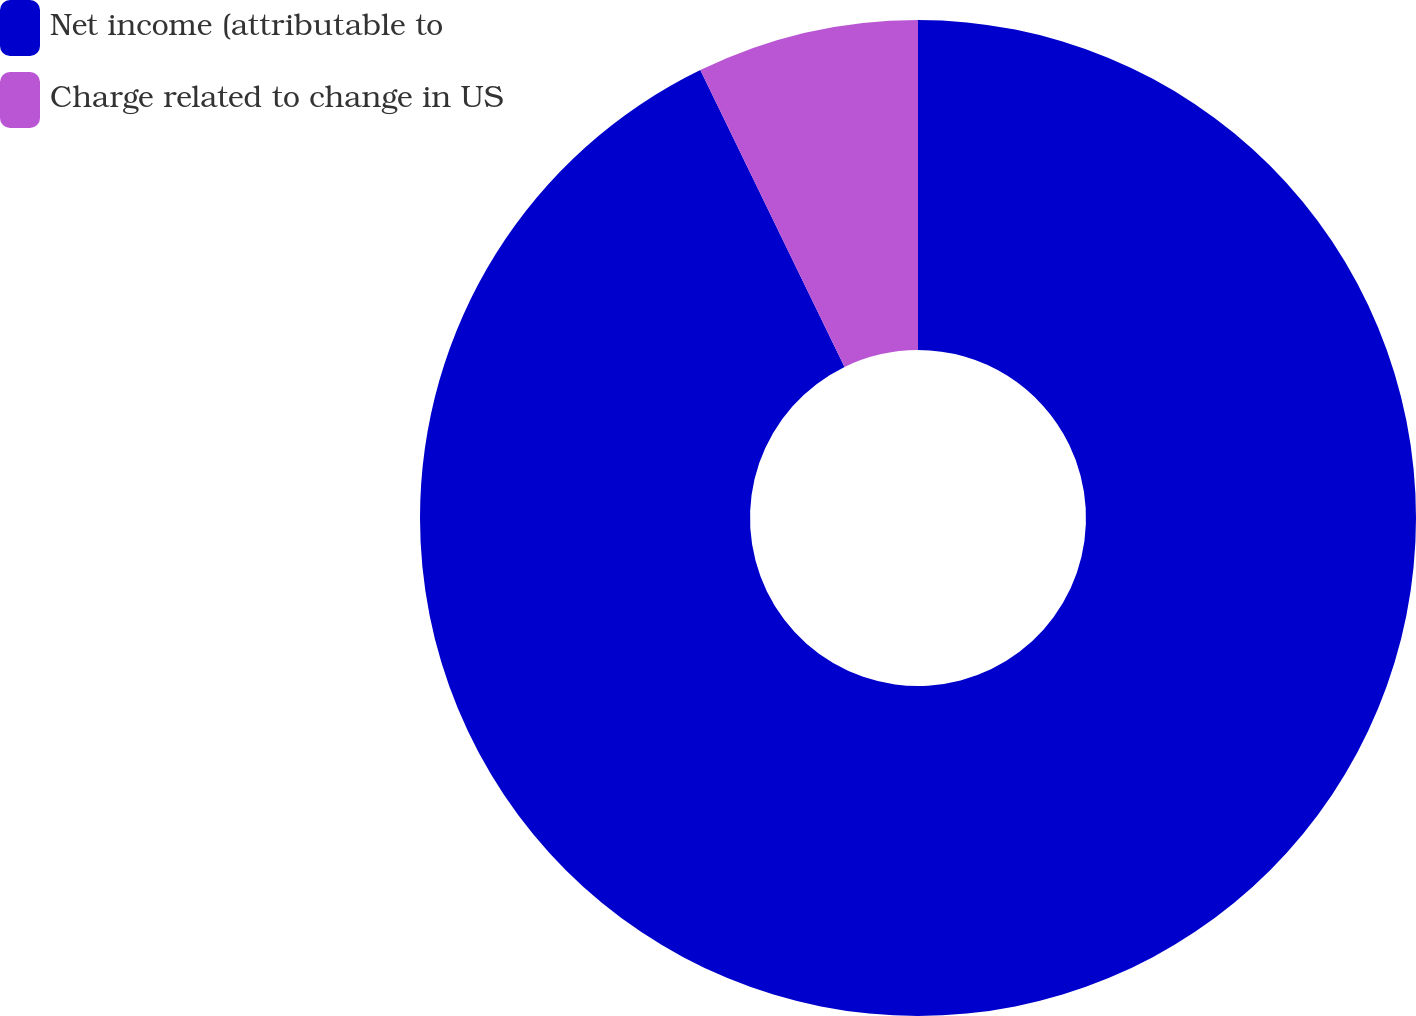Convert chart to OTSL. <chart><loc_0><loc_0><loc_500><loc_500><pie_chart><fcel>Net income (attributable to<fcel>Charge related to change in US<nl><fcel>92.8%<fcel>7.2%<nl></chart> 